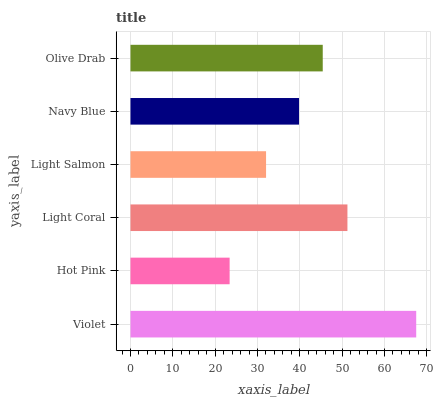Is Hot Pink the minimum?
Answer yes or no. Yes. Is Violet the maximum?
Answer yes or no. Yes. Is Light Coral the minimum?
Answer yes or no. No. Is Light Coral the maximum?
Answer yes or no. No. Is Light Coral greater than Hot Pink?
Answer yes or no. Yes. Is Hot Pink less than Light Coral?
Answer yes or no. Yes. Is Hot Pink greater than Light Coral?
Answer yes or no. No. Is Light Coral less than Hot Pink?
Answer yes or no. No. Is Olive Drab the high median?
Answer yes or no. Yes. Is Navy Blue the low median?
Answer yes or no. Yes. Is Light Salmon the high median?
Answer yes or no. No. Is Violet the low median?
Answer yes or no. No. 